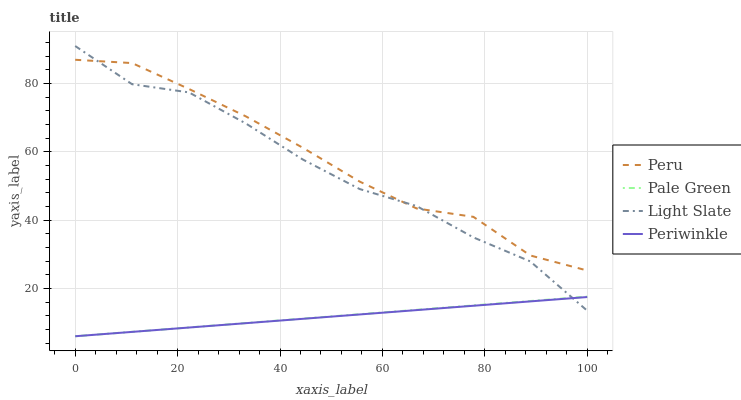Does Periwinkle have the minimum area under the curve?
Answer yes or no. Yes. Does Peru have the maximum area under the curve?
Answer yes or no. Yes. Does Pale Green have the minimum area under the curve?
Answer yes or no. No. Does Pale Green have the maximum area under the curve?
Answer yes or no. No. Is Pale Green the smoothest?
Answer yes or no. Yes. Is Light Slate the roughest?
Answer yes or no. Yes. Is Periwinkle the smoothest?
Answer yes or no. No. Is Periwinkle the roughest?
Answer yes or no. No. Does Pale Green have the lowest value?
Answer yes or no. Yes. Does Peru have the lowest value?
Answer yes or no. No. Does Light Slate have the highest value?
Answer yes or no. Yes. Does Pale Green have the highest value?
Answer yes or no. No. Is Pale Green less than Peru?
Answer yes or no. Yes. Is Peru greater than Periwinkle?
Answer yes or no. Yes. Does Periwinkle intersect Pale Green?
Answer yes or no. Yes. Is Periwinkle less than Pale Green?
Answer yes or no. No. Is Periwinkle greater than Pale Green?
Answer yes or no. No. Does Pale Green intersect Peru?
Answer yes or no. No. 